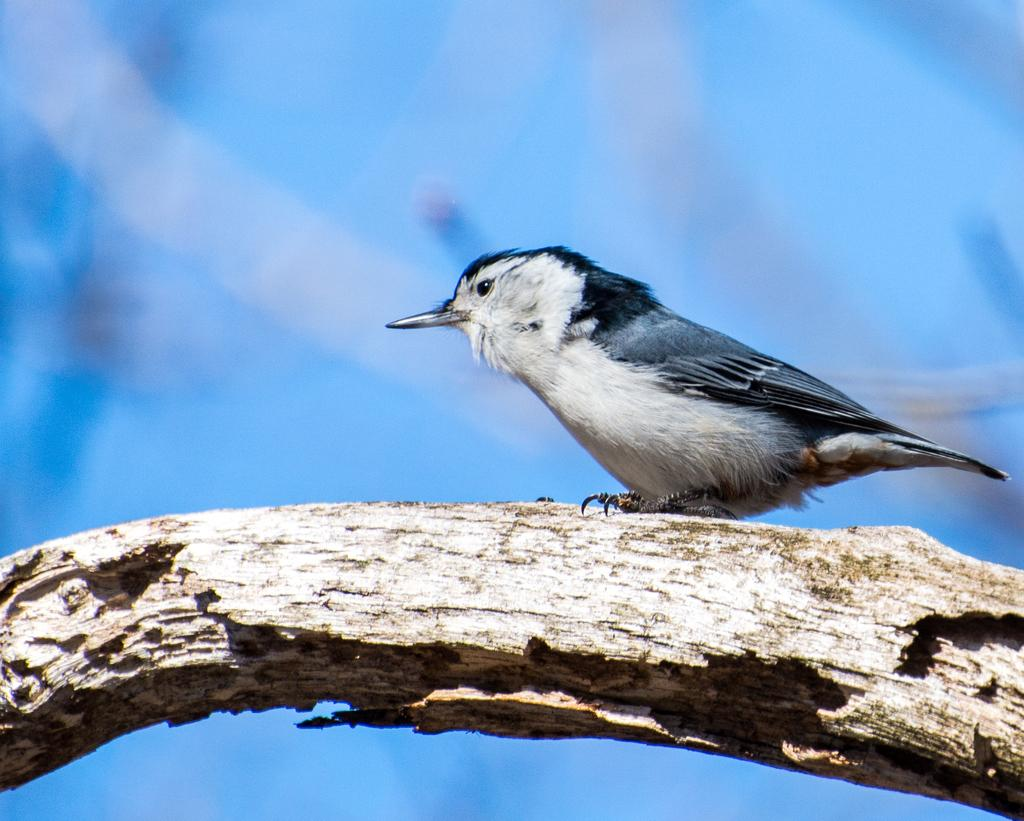What type of animal is in the image? There is a bird in the image. What color is the bird? The bird is black in color. Where is the bird located in the image? The bird is on the branch of a tree. What subject is the woman teaching in the image? There is no woman or teaching activity present in the image; it features a black bird on a tree branch. 